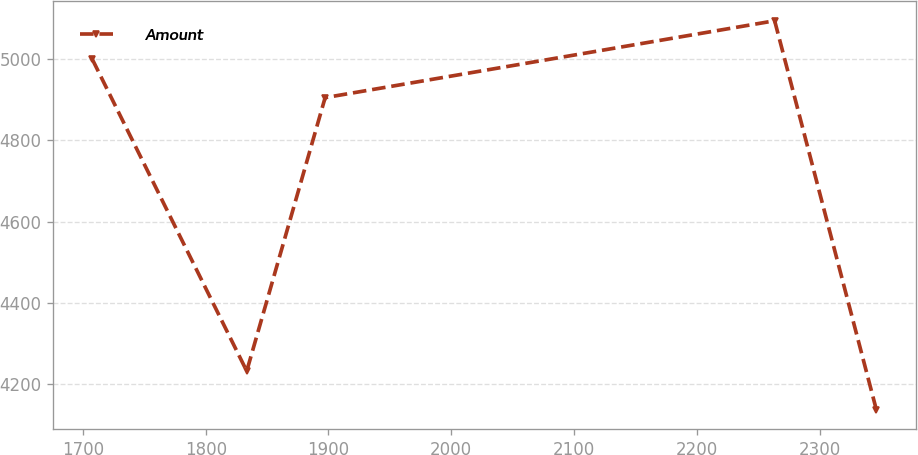Convert chart. <chart><loc_0><loc_0><loc_500><loc_500><line_chart><ecel><fcel>Amount<nl><fcel>1707.61<fcel>4998.55<nl><fcel>1833.42<fcel>4232.74<nl><fcel>1897.28<fcel>4904.18<nl><fcel>2263.44<fcel>5092.92<nl><fcel>2346.24<fcel>4138.37<nl></chart> 